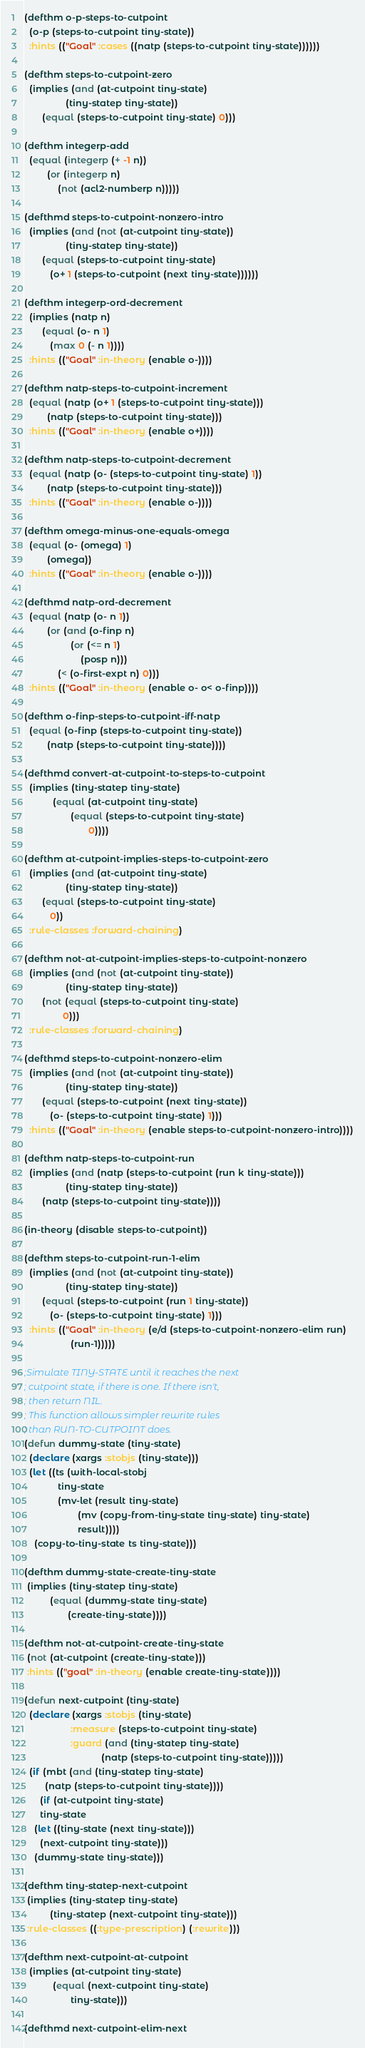<code> <loc_0><loc_0><loc_500><loc_500><_Lisp_>
(defthm o-p-steps-to-cutpoint
  (o-p (steps-to-cutpoint tiny-state))
  :hints (("Goal" :cases ((natp (steps-to-cutpoint tiny-state))))))

(defthm steps-to-cutpoint-zero
  (implies (and (at-cutpoint tiny-state)
                (tiny-statep tiny-state))
	   (equal (steps-to-cutpoint tiny-state) 0)))

(defthm integerp-add
  (equal (integerp (+ -1 n))
         (or (integerp n)
             (not (acl2-numberp n)))))

(defthmd steps-to-cutpoint-nonzero-intro
  (implies (and (not (at-cutpoint tiny-state))
                (tiny-statep tiny-state))
	   (equal (steps-to-cutpoint tiny-state)
		  (o+ 1 (steps-to-cutpoint (next tiny-state))))))
  
(defthm integerp-ord-decrement
  (implies (natp n)
	   (equal (o- n 1)
		  (max 0 (- n 1))))
  :hints (("Goal" :in-theory (enable o-))))

(defthm natp-steps-to-cutpoint-increment
  (equal (natp (o+ 1 (steps-to-cutpoint tiny-state)))
         (natp (steps-to-cutpoint tiny-state)))
  :hints (("Goal" :in-theory (enable o+))))

(defthm natp-steps-to-cutpoint-decrement
  (equal (natp (o- (steps-to-cutpoint tiny-state) 1))
         (natp (steps-to-cutpoint tiny-state)))
  :hints (("Goal" :in-theory (enable o-))))

(defthm omega-minus-one-equals-omega
  (equal (o- (omega) 1)
         (omega))
  :hints (("Goal" :in-theory (enable o-))))

(defthmd natp-ord-decrement
  (equal (natp (o- n 1))
         (or (and (o-finp n)
                  (or (<= n 1)
                      (posp n)))
             (< (o-first-expt n) 0)))
  :hints (("Goal" :in-theory (enable o- o< o-finp))))

(defthm o-finp-steps-to-cutpoint-iff-natp
  (equal (o-finp (steps-to-cutpoint tiny-state))
         (natp (steps-to-cutpoint tiny-state))))

(defthmd convert-at-cutpoint-to-steps-to-cutpoint
  (implies (tiny-statep tiny-state)
           (equal (at-cutpoint tiny-state)
                  (equal (steps-to-cutpoint tiny-state)
                         0))))

(defthm at-cutpoint-implies-steps-to-cutpoint-zero
  (implies (and (at-cutpoint tiny-state)
                (tiny-statep tiny-state))
	   (equal (steps-to-cutpoint tiny-state)
		  0))	   
  :rule-classes :forward-chaining)

(defthm not-at-cutpoint-implies-steps-to-cutpoint-nonzero
  (implies (and (not (at-cutpoint tiny-state))
                (tiny-statep tiny-state))
	   (not (equal (steps-to-cutpoint tiny-state)
		       0)))	   
  :rule-classes :forward-chaining)

(defthmd steps-to-cutpoint-nonzero-elim
  (implies (and (not (at-cutpoint tiny-state))
                (tiny-statep tiny-state))
	   (equal (steps-to-cutpoint (next tiny-state))
		  (o- (steps-to-cutpoint tiny-state) 1)))
  :hints (("Goal" :in-theory (enable steps-to-cutpoint-nonzero-intro))))

(defthm natp-steps-to-cutpoint-run
  (implies (and (natp (steps-to-cutpoint (run k tiny-state)))
                (tiny-statep tiny-state))
	   (natp (steps-to-cutpoint tiny-state))))

(in-theory (disable steps-to-cutpoint))

(defthm steps-to-cutpoint-run-1-elim
  (implies (and (not (at-cutpoint tiny-state))
                (tiny-statep tiny-state))
	   (equal (steps-to-cutpoint (run 1 tiny-state))
		  (o- (steps-to-cutpoint tiny-state) 1)))
  :hints (("Goal" :in-theory (e/d (steps-to-cutpoint-nonzero-elim run)
				  (run-1)))))

;Simulate TINY-STATE until it reaches the next
; cutpoint state, if there is one. If there isn't,
; then return NIL.
; This function allows simpler rewrite rules
; than RUN-TO-CUTPOINT does.
(defun dummy-state (tiny-state)
  (declare (xargs :stobjs (tiny-state)))
  (let ((ts (with-local-stobj
             tiny-state
             (mv-let (result tiny-state)
                     (mv (copy-from-tiny-state tiny-state) tiny-state)
                     result))))
    (copy-to-tiny-state ts tiny-state)))

(defthm dummy-state-create-tiny-state
 (implies (tiny-statep tiny-state)
          (equal (dummy-state tiny-state)
                 (create-tiny-state))))

(defthm not-at-cutpoint-create-tiny-state
 (not (at-cutpoint (create-tiny-state)))
 :hints (("goal" :in-theory (enable create-tiny-state))))

(defun next-cutpoint (tiny-state)
  (declare (xargs :stobjs (tiny-state)
                  :measure (steps-to-cutpoint tiny-state)
                  :guard (and (tiny-statep tiny-state)
                              (natp (steps-to-cutpoint tiny-state)))))
  (if (mbt (and (tiny-statep tiny-state)
		(natp (steps-to-cutpoint tiny-state))))
      (if (at-cutpoint tiny-state) 
	  tiny-state
	(let ((tiny-state (next tiny-state)))
	  (next-cutpoint tiny-state)))
    (dummy-state tiny-state)))

(defthm tiny-statep-next-cutpoint
 (implies (tiny-statep tiny-state)
          (tiny-statep (next-cutpoint tiny-state)))
 :rule-classes ((:type-prescription) (:rewrite)))

(defthm next-cutpoint-at-cutpoint
  (implies (at-cutpoint tiny-state)
           (equal (next-cutpoint tiny-state)
                  tiny-state)))
 
(defthmd next-cutpoint-elim-next</code> 